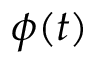<formula> <loc_0><loc_0><loc_500><loc_500>\phi ( t )</formula> 